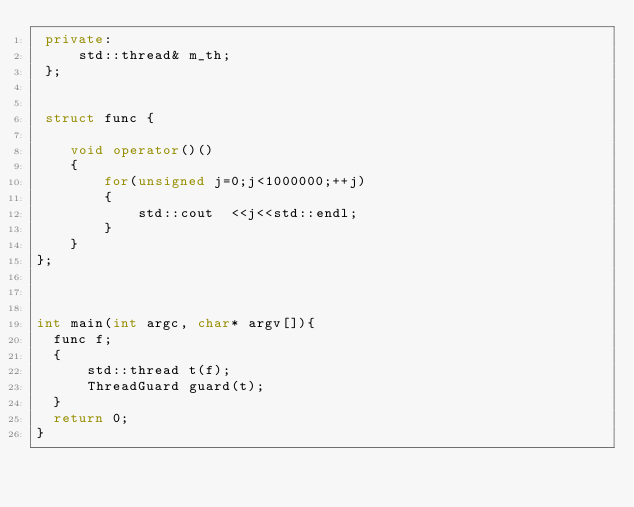Convert code to text. <code><loc_0><loc_0><loc_500><loc_500><_C++_> private:
     std::thread& m_th;
 };


 struct func {

    void operator()()
    {
        for(unsigned j=0;j<1000000;++j)
        {
            std::cout  <<j<<std::endl;
        }
    }
};



int main(int argc, char* argv[]){
  func f;
  {
      std::thread t(f);
      ThreadGuard guard(t);
  }
  return 0;
}

</code> 